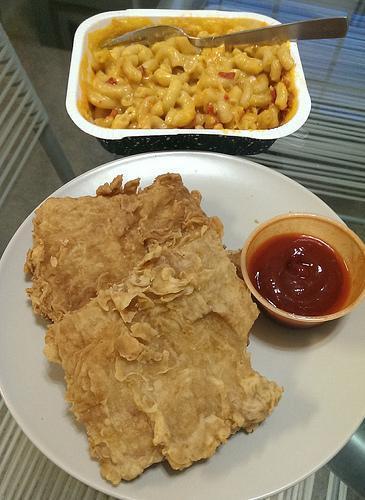How many ketchups are there?
Give a very brief answer. 1. 